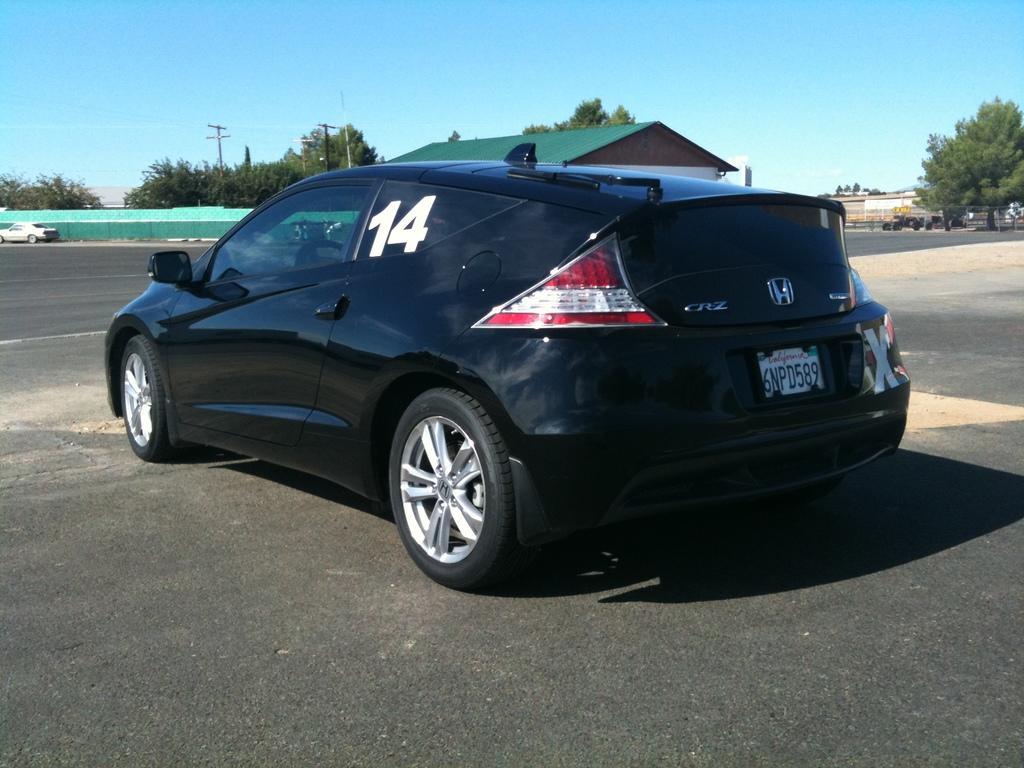Please provide a concise description of this image. In this image, we can see a black car is parked on the road. Background we can see walls, trees, houses, poles and sky. On the left side of the image, there is a white car. 